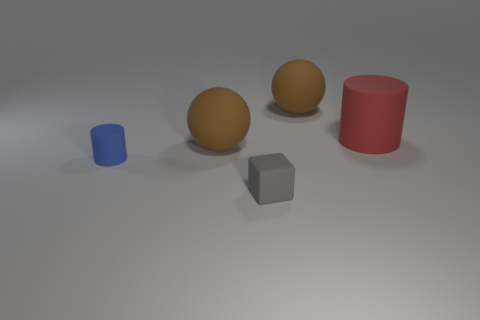Is the color of the tiny matte cylinder the same as the tiny matte thing that is to the right of the blue rubber object?
Keep it short and to the point. No. What is the shape of the small gray rubber thing?
Give a very brief answer. Cube. What is the size of the matte cylinder in front of the large rubber sphere on the left side of the object that is in front of the tiny blue cylinder?
Give a very brief answer. Small. How many other objects are the same shape as the blue thing?
Provide a short and direct response. 1. There is a big object that is behind the big red object; does it have the same shape as the large object to the left of the rubber cube?
Make the answer very short. Yes. What number of cubes are either tiny gray rubber objects or red objects?
Your answer should be compact. 1. What material is the sphere that is in front of the large red cylinder that is in front of the big brown matte object behind the large red object made of?
Provide a short and direct response. Rubber. How many other things are there of the same size as the red cylinder?
Provide a short and direct response. 2. Is the number of gray objects behind the small gray matte object greater than the number of large brown matte things?
Your answer should be very brief. No. Are there any other matte blocks that have the same color as the tiny cube?
Provide a succinct answer. No. 